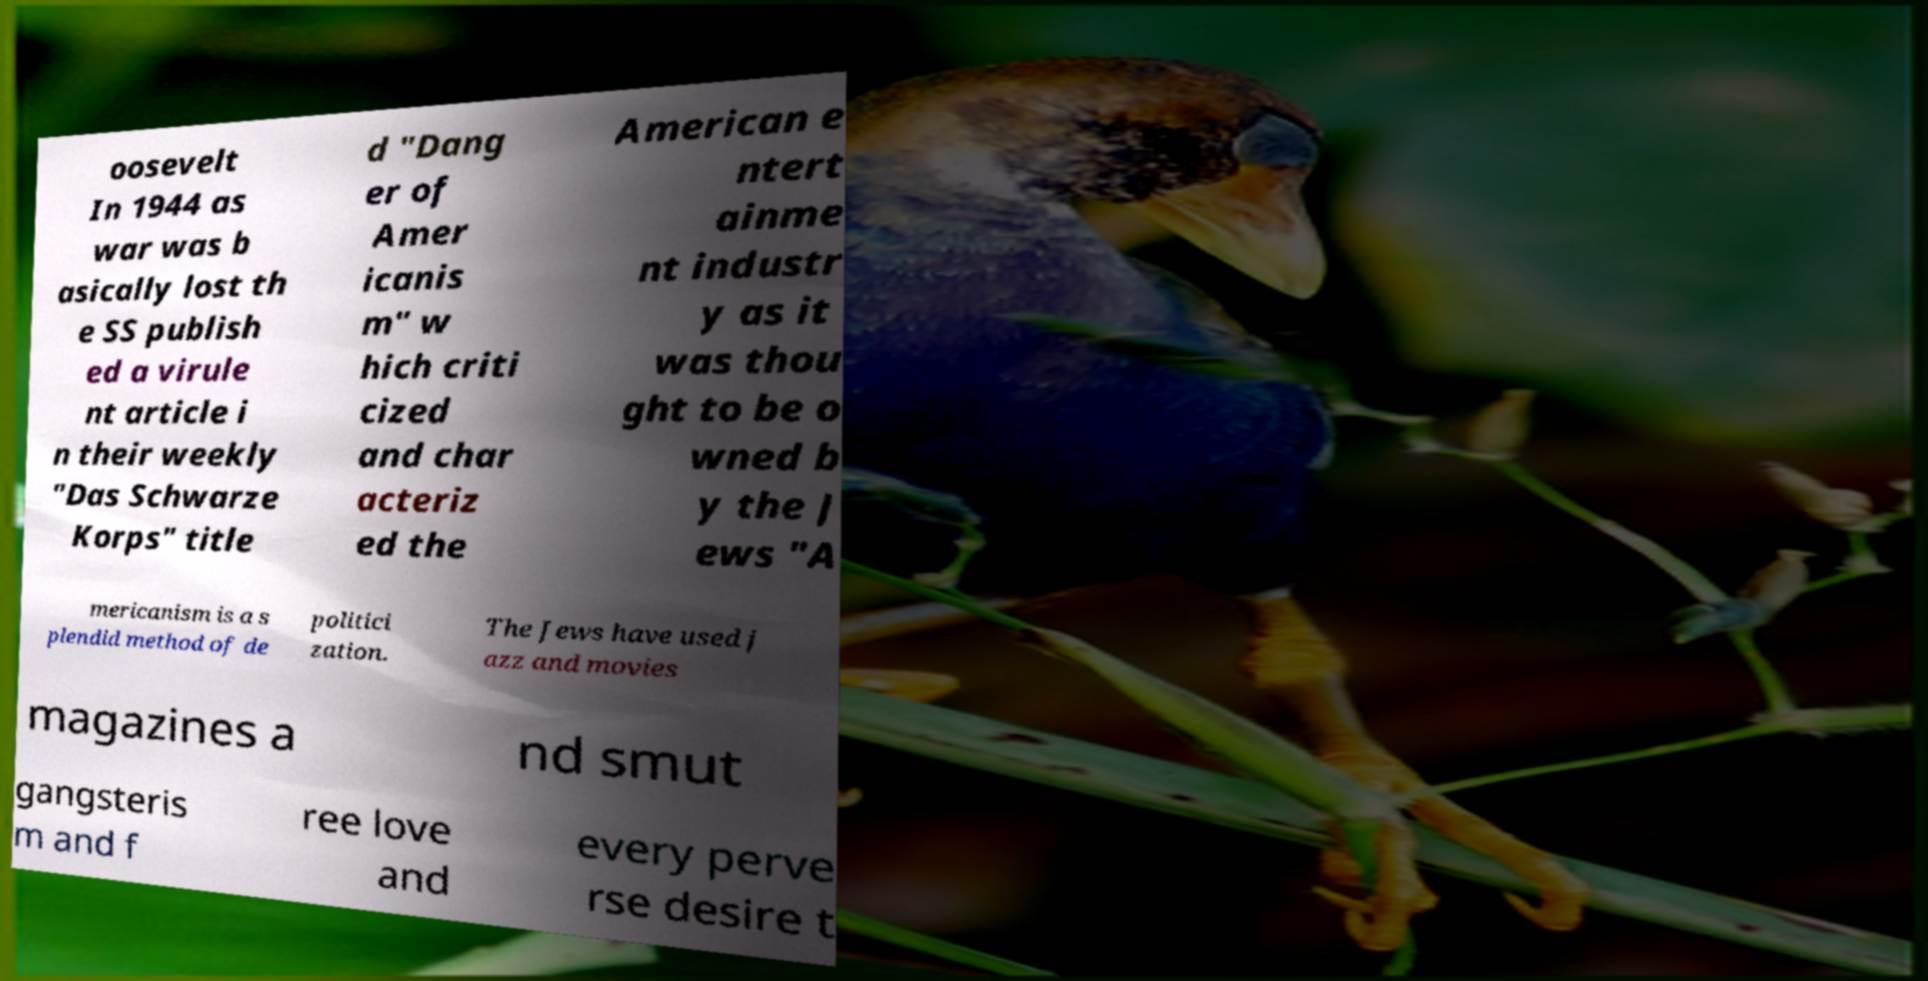There's text embedded in this image that I need extracted. Can you transcribe it verbatim? oosevelt In 1944 as war was b asically lost th e SS publish ed a virule nt article i n their weekly "Das Schwarze Korps" title d "Dang er of Amer icanis m" w hich criti cized and char acteriz ed the American e ntert ainme nt industr y as it was thou ght to be o wned b y the J ews "A mericanism is a s plendid method of de politici zation. The Jews have used j azz and movies magazines a nd smut gangsteris m and f ree love and every perve rse desire t 